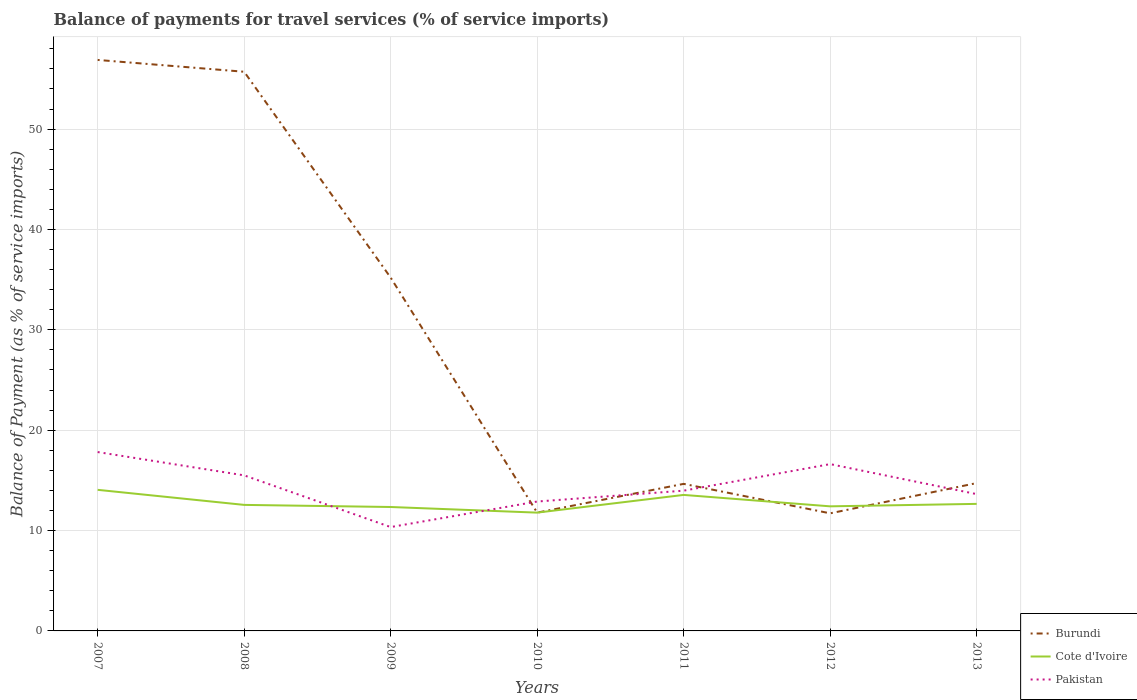Is the number of lines equal to the number of legend labels?
Provide a short and direct response. Yes. Across all years, what is the maximum balance of payments for travel services in Cote d'Ivoire?
Your response must be concise. 11.79. What is the total balance of payments for travel services in Cote d'Ivoire in the graph?
Provide a short and direct response. 0.21. What is the difference between the highest and the second highest balance of payments for travel services in Pakistan?
Ensure brevity in your answer.  7.47. What is the difference between the highest and the lowest balance of payments for travel services in Burundi?
Offer a very short reply. 3. Is the balance of payments for travel services in Pakistan strictly greater than the balance of payments for travel services in Cote d'Ivoire over the years?
Provide a short and direct response. No. What is the difference between two consecutive major ticks on the Y-axis?
Offer a terse response. 10. Where does the legend appear in the graph?
Make the answer very short. Bottom right. How are the legend labels stacked?
Your answer should be very brief. Vertical. What is the title of the graph?
Keep it short and to the point. Balance of payments for travel services (% of service imports). Does "India" appear as one of the legend labels in the graph?
Offer a terse response. No. What is the label or title of the Y-axis?
Your response must be concise. Balance of Payment (as % of service imports). What is the Balance of Payment (as % of service imports) of Burundi in 2007?
Make the answer very short. 56.89. What is the Balance of Payment (as % of service imports) of Cote d'Ivoire in 2007?
Your response must be concise. 14.06. What is the Balance of Payment (as % of service imports) in Pakistan in 2007?
Provide a succinct answer. 17.82. What is the Balance of Payment (as % of service imports) in Burundi in 2008?
Your answer should be compact. 55.71. What is the Balance of Payment (as % of service imports) in Cote d'Ivoire in 2008?
Keep it short and to the point. 12.56. What is the Balance of Payment (as % of service imports) in Pakistan in 2008?
Give a very brief answer. 15.5. What is the Balance of Payment (as % of service imports) of Burundi in 2009?
Make the answer very short. 35.2. What is the Balance of Payment (as % of service imports) in Cote d'Ivoire in 2009?
Give a very brief answer. 12.35. What is the Balance of Payment (as % of service imports) of Pakistan in 2009?
Ensure brevity in your answer.  10.35. What is the Balance of Payment (as % of service imports) of Burundi in 2010?
Offer a very short reply. 11.79. What is the Balance of Payment (as % of service imports) in Cote d'Ivoire in 2010?
Give a very brief answer. 11.79. What is the Balance of Payment (as % of service imports) in Pakistan in 2010?
Give a very brief answer. 12.89. What is the Balance of Payment (as % of service imports) in Burundi in 2011?
Your answer should be very brief. 14.65. What is the Balance of Payment (as % of service imports) of Cote d'Ivoire in 2011?
Your answer should be very brief. 13.55. What is the Balance of Payment (as % of service imports) in Pakistan in 2011?
Give a very brief answer. 13.97. What is the Balance of Payment (as % of service imports) in Burundi in 2012?
Give a very brief answer. 11.72. What is the Balance of Payment (as % of service imports) of Cote d'Ivoire in 2012?
Give a very brief answer. 12.41. What is the Balance of Payment (as % of service imports) in Pakistan in 2012?
Give a very brief answer. 16.62. What is the Balance of Payment (as % of service imports) in Burundi in 2013?
Ensure brevity in your answer.  14.73. What is the Balance of Payment (as % of service imports) in Cote d'Ivoire in 2013?
Provide a succinct answer. 12.66. What is the Balance of Payment (as % of service imports) in Pakistan in 2013?
Give a very brief answer. 13.63. Across all years, what is the maximum Balance of Payment (as % of service imports) in Burundi?
Keep it short and to the point. 56.89. Across all years, what is the maximum Balance of Payment (as % of service imports) of Cote d'Ivoire?
Your answer should be compact. 14.06. Across all years, what is the maximum Balance of Payment (as % of service imports) of Pakistan?
Give a very brief answer. 17.82. Across all years, what is the minimum Balance of Payment (as % of service imports) in Burundi?
Give a very brief answer. 11.72. Across all years, what is the minimum Balance of Payment (as % of service imports) in Cote d'Ivoire?
Ensure brevity in your answer.  11.79. Across all years, what is the minimum Balance of Payment (as % of service imports) in Pakistan?
Ensure brevity in your answer.  10.35. What is the total Balance of Payment (as % of service imports) in Burundi in the graph?
Your response must be concise. 200.68. What is the total Balance of Payment (as % of service imports) of Cote d'Ivoire in the graph?
Offer a terse response. 89.37. What is the total Balance of Payment (as % of service imports) in Pakistan in the graph?
Make the answer very short. 100.78. What is the difference between the Balance of Payment (as % of service imports) in Burundi in 2007 and that in 2008?
Your answer should be compact. 1.18. What is the difference between the Balance of Payment (as % of service imports) in Pakistan in 2007 and that in 2008?
Provide a short and direct response. 2.32. What is the difference between the Balance of Payment (as % of service imports) in Burundi in 2007 and that in 2009?
Offer a terse response. 21.69. What is the difference between the Balance of Payment (as % of service imports) of Cote d'Ivoire in 2007 and that in 2009?
Your answer should be compact. 1.71. What is the difference between the Balance of Payment (as % of service imports) in Pakistan in 2007 and that in 2009?
Provide a short and direct response. 7.47. What is the difference between the Balance of Payment (as % of service imports) of Burundi in 2007 and that in 2010?
Your answer should be compact. 45.1. What is the difference between the Balance of Payment (as % of service imports) of Cote d'Ivoire in 2007 and that in 2010?
Offer a terse response. 2.27. What is the difference between the Balance of Payment (as % of service imports) in Pakistan in 2007 and that in 2010?
Your answer should be compact. 4.93. What is the difference between the Balance of Payment (as % of service imports) of Burundi in 2007 and that in 2011?
Ensure brevity in your answer.  42.24. What is the difference between the Balance of Payment (as % of service imports) in Cote d'Ivoire in 2007 and that in 2011?
Provide a short and direct response. 0.51. What is the difference between the Balance of Payment (as % of service imports) in Pakistan in 2007 and that in 2011?
Give a very brief answer. 3.85. What is the difference between the Balance of Payment (as % of service imports) in Burundi in 2007 and that in 2012?
Your answer should be compact. 45.17. What is the difference between the Balance of Payment (as % of service imports) of Cote d'Ivoire in 2007 and that in 2012?
Your response must be concise. 1.64. What is the difference between the Balance of Payment (as % of service imports) in Pakistan in 2007 and that in 2012?
Offer a very short reply. 1.2. What is the difference between the Balance of Payment (as % of service imports) in Burundi in 2007 and that in 2013?
Make the answer very short. 42.16. What is the difference between the Balance of Payment (as % of service imports) in Cote d'Ivoire in 2007 and that in 2013?
Ensure brevity in your answer.  1.4. What is the difference between the Balance of Payment (as % of service imports) of Pakistan in 2007 and that in 2013?
Make the answer very short. 4.19. What is the difference between the Balance of Payment (as % of service imports) in Burundi in 2008 and that in 2009?
Make the answer very short. 20.51. What is the difference between the Balance of Payment (as % of service imports) in Cote d'Ivoire in 2008 and that in 2009?
Make the answer very short. 0.21. What is the difference between the Balance of Payment (as % of service imports) of Pakistan in 2008 and that in 2009?
Provide a short and direct response. 5.15. What is the difference between the Balance of Payment (as % of service imports) in Burundi in 2008 and that in 2010?
Offer a very short reply. 43.93. What is the difference between the Balance of Payment (as % of service imports) of Cote d'Ivoire in 2008 and that in 2010?
Provide a short and direct response. 0.77. What is the difference between the Balance of Payment (as % of service imports) in Pakistan in 2008 and that in 2010?
Provide a succinct answer. 2.61. What is the difference between the Balance of Payment (as % of service imports) of Burundi in 2008 and that in 2011?
Your answer should be compact. 41.06. What is the difference between the Balance of Payment (as % of service imports) of Cote d'Ivoire in 2008 and that in 2011?
Your answer should be very brief. -0.99. What is the difference between the Balance of Payment (as % of service imports) of Pakistan in 2008 and that in 2011?
Keep it short and to the point. 1.52. What is the difference between the Balance of Payment (as % of service imports) of Burundi in 2008 and that in 2012?
Make the answer very short. 44. What is the difference between the Balance of Payment (as % of service imports) of Cote d'Ivoire in 2008 and that in 2012?
Provide a short and direct response. 0.14. What is the difference between the Balance of Payment (as % of service imports) in Pakistan in 2008 and that in 2012?
Your response must be concise. -1.12. What is the difference between the Balance of Payment (as % of service imports) in Burundi in 2008 and that in 2013?
Your response must be concise. 40.98. What is the difference between the Balance of Payment (as % of service imports) of Cote d'Ivoire in 2008 and that in 2013?
Your answer should be compact. -0.1. What is the difference between the Balance of Payment (as % of service imports) in Pakistan in 2008 and that in 2013?
Your response must be concise. 1.87. What is the difference between the Balance of Payment (as % of service imports) of Burundi in 2009 and that in 2010?
Provide a succinct answer. 23.42. What is the difference between the Balance of Payment (as % of service imports) of Cote d'Ivoire in 2009 and that in 2010?
Make the answer very short. 0.56. What is the difference between the Balance of Payment (as % of service imports) in Pakistan in 2009 and that in 2010?
Make the answer very short. -2.55. What is the difference between the Balance of Payment (as % of service imports) of Burundi in 2009 and that in 2011?
Offer a very short reply. 20.55. What is the difference between the Balance of Payment (as % of service imports) of Cote d'Ivoire in 2009 and that in 2011?
Offer a terse response. -1.2. What is the difference between the Balance of Payment (as % of service imports) of Pakistan in 2009 and that in 2011?
Give a very brief answer. -3.63. What is the difference between the Balance of Payment (as % of service imports) in Burundi in 2009 and that in 2012?
Keep it short and to the point. 23.48. What is the difference between the Balance of Payment (as % of service imports) in Cote d'Ivoire in 2009 and that in 2012?
Make the answer very short. -0.07. What is the difference between the Balance of Payment (as % of service imports) in Pakistan in 2009 and that in 2012?
Provide a succinct answer. -6.27. What is the difference between the Balance of Payment (as % of service imports) in Burundi in 2009 and that in 2013?
Keep it short and to the point. 20.47. What is the difference between the Balance of Payment (as % of service imports) in Cote d'Ivoire in 2009 and that in 2013?
Offer a very short reply. -0.31. What is the difference between the Balance of Payment (as % of service imports) in Pakistan in 2009 and that in 2013?
Ensure brevity in your answer.  -3.28. What is the difference between the Balance of Payment (as % of service imports) in Burundi in 2010 and that in 2011?
Make the answer very short. -2.87. What is the difference between the Balance of Payment (as % of service imports) of Cote d'Ivoire in 2010 and that in 2011?
Provide a short and direct response. -1.76. What is the difference between the Balance of Payment (as % of service imports) in Pakistan in 2010 and that in 2011?
Make the answer very short. -1.08. What is the difference between the Balance of Payment (as % of service imports) in Burundi in 2010 and that in 2012?
Provide a succinct answer. 0.07. What is the difference between the Balance of Payment (as % of service imports) of Cote d'Ivoire in 2010 and that in 2012?
Give a very brief answer. -0.63. What is the difference between the Balance of Payment (as % of service imports) of Pakistan in 2010 and that in 2012?
Offer a terse response. -3.73. What is the difference between the Balance of Payment (as % of service imports) of Burundi in 2010 and that in 2013?
Provide a short and direct response. -2.94. What is the difference between the Balance of Payment (as % of service imports) of Cote d'Ivoire in 2010 and that in 2013?
Keep it short and to the point. -0.87. What is the difference between the Balance of Payment (as % of service imports) of Pakistan in 2010 and that in 2013?
Provide a succinct answer. -0.74. What is the difference between the Balance of Payment (as % of service imports) of Burundi in 2011 and that in 2012?
Offer a very short reply. 2.94. What is the difference between the Balance of Payment (as % of service imports) of Cote d'Ivoire in 2011 and that in 2012?
Your answer should be compact. 1.14. What is the difference between the Balance of Payment (as % of service imports) in Pakistan in 2011 and that in 2012?
Your answer should be very brief. -2.64. What is the difference between the Balance of Payment (as % of service imports) in Burundi in 2011 and that in 2013?
Your answer should be compact. -0.08. What is the difference between the Balance of Payment (as % of service imports) of Cote d'Ivoire in 2011 and that in 2013?
Provide a short and direct response. 0.89. What is the difference between the Balance of Payment (as % of service imports) in Pakistan in 2011 and that in 2013?
Make the answer very short. 0.34. What is the difference between the Balance of Payment (as % of service imports) of Burundi in 2012 and that in 2013?
Your answer should be very brief. -3.01. What is the difference between the Balance of Payment (as % of service imports) of Cote d'Ivoire in 2012 and that in 2013?
Make the answer very short. -0.25. What is the difference between the Balance of Payment (as % of service imports) in Pakistan in 2012 and that in 2013?
Offer a terse response. 2.99. What is the difference between the Balance of Payment (as % of service imports) of Burundi in 2007 and the Balance of Payment (as % of service imports) of Cote d'Ivoire in 2008?
Offer a terse response. 44.33. What is the difference between the Balance of Payment (as % of service imports) in Burundi in 2007 and the Balance of Payment (as % of service imports) in Pakistan in 2008?
Provide a succinct answer. 41.39. What is the difference between the Balance of Payment (as % of service imports) in Cote d'Ivoire in 2007 and the Balance of Payment (as % of service imports) in Pakistan in 2008?
Offer a very short reply. -1.44. What is the difference between the Balance of Payment (as % of service imports) in Burundi in 2007 and the Balance of Payment (as % of service imports) in Cote d'Ivoire in 2009?
Ensure brevity in your answer.  44.54. What is the difference between the Balance of Payment (as % of service imports) in Burundi in 2007 and the Balance of Payment (as % of service imports) in Pakistan in 2009?
Offer a very short reply. 46.54. What is the difference between the Balance of Payment (as % of service imports) of Cote d'Ivoire in 2007 and the Balance of Payment (as % of service imports) of Pakistan in 2009?
Offer a terse response. 3.71. What is the difference between the Balance of Payment (as % of service imports) of Burundi in 2007 and the Balance of Payment (as % of service imports) of Cote d'Ivoire in 2010?
Your answer should be compact. 45.1. What is the difference between the Balance of Payment (as % of service imports) in Burundi in 2007 and the Balance of Payment (as % of service imports) in Pakistan in 2010?
Your answer should be compact. 44. What is the difference between the Balance of Payment (as % of service imports) in Cote d'Ivoire in 2007 and the Balance of Payment (as % of service imports) in Pakistan in 2010?
Keep it short and to the point. 1.16. What is the difference between the Balance of Payment (as % of service imports) in Burundi in 2007 and the Balance of Payment (as % of service imports) in Cote d'Ivoire in 2011?
Provide a succinct answer. 43.34. What is the difference between the Balance of Payment (as % of service imports) of Burundi in 2007 and the Balance of Payment (as % of service imports) of Pakistan in 2011?
Keep it short and to the point. 42.91. What is the difference between the Balance of Payment (as % of service imports) of Cote d'Ivoire in 2007 and the Balance of Payment (as % of service imports) of Pakistan in 2011?
Ensure brevity in your answer.  0.08. What is the difference between the Balance of Payment (as % of service imports) in Burundi in 2007 and the Balance of Payment (as % of service imports) in Cote d'Ivoire in 2012?
Give a very brief answer. 44.48. What is the difference between the Balance of Payment (as % of service imports) in Burundi in 2007 and the Balance of Payment (as % of service imports) in Pakistan in 2012?
Your answer should be very brief. 40.27. What is the difference between the Balance of Payment (as % of service imports) in Cote d'Ivoire in 2007 and the Balance of Payment (as % of service imports) in Pakistan in 2012?
Offer a terse response. -2.56. What is the difference between the Balance of Payment (as % of service imports) in Burundi in 2007 and the Balance of Payment (as % of service imports) in Cote d'Ivoire in 2013?
Provide a short and direct response. 44.23. What is the difference between the Balance of Payment (as % of service imports) of Burundi in 2007 and the Balance of Payment (as % of service imports) of Pakistan in 2013?
Your answer should be compact. 43.26. What is the difference between the Balance of Payment (as % of service imports) of Cote d'Ivoire in 2007 and the Balance of Payment (as % of service imports) of Pakistan in 2013?
Offer a terse response. 0.43. What is the difference between the Balance of Payment (as % of service imports) of Burundi in 2008 and the Balance of Payment (as % of service imports) of Cote d'Ivoire in 2009?
Keep it short and to the point. 43.37. What is the difference between the Balance of Payment (as % of service imports) of Burundi in 2008 and the Balance of Payment (as % of service imports) of Pakistan in 2009?
Ensure brevity in your answer.  45.36. What is the difference between the Balance of Payment (as % of service imports) in Cote d'Ivoire in 2008 and the Balance of Payment (as % of service imports) in Pakistan in 2009?
Your answer should be compact. 2.21. What is the difference between the Balance of Payment (as % of service imports) in Burundi in 2008 and the Balance of Payment (as % of service imports) in Cote d'Ivoire in 2010?
Give a very brief answer. 43.92. What is the difference between the Balance of Payment (as % of service imports) of Burundi in 2008 and the Balance of Payment (as % of service imports) of Pakistan in 2010?
Offer a very short reply. 42.82. What is the difference between the Balance of Payment (as % of service imports) in Cote d'Ivoire in 2008 and the Balance of Payment (as % of service imports) in Pakistan in 2010?
Your answer should be very brief. -0.34. What is the difference between the Balance of Payment (as % of service imports) of Burundi in 2008 and the Balance of Payment (as % of service imports) of Cote d'Ivoire in 2011?
Provide a succinct answer. 42.16. What is the difference between the Balance of Payment (as % of service imports) of Burundi in 2008 and the Balance of Payment (as % of service imports) of Pakistan in 2011?
Your response must be concise. 41.74. What is the difference between the Balance of Payment (as % of service imports) of Cote d'Ivoire in 2008 and the Balance of Payment (as % of service imports) of Pakistan in 2011?
Your answer should be very brief. -1.42. What is the difference between the Balance of Payment (as % of service imports) in Burundi in 2008 and the Balance of Payment (as % of service imports) in Cote d'Ivoire in 2012?
Your answer should be compact. 43.3. What is the difference between the Balance of Payment (as % of service imports) in Burundi in 2008 and the Balance of Payment (as % of service imports) in Pakistan in 2012?
Ensure brevity in your answer.  39.09. What is the difference between the Balance of Payment (as % of service imports) in Cote d'Ivoire in 2008 and the Balance of Payment (as % of service imports) in Pakistan in 2012?
Give a very brief answer. -4.06. What is the difference between the Balance of Payment (as % of service imports) in Burundi in 2008 and the Balance of Payment (as % of service imports) in Cote d'Ivoire in 2013?
Provide a succinct answer. 43.05. What is the difference between the Balance of Payment (as % of service imports) of Burundi in 2008 and the Balance of Payment (as % of service imports) of Pakistan in 2013?
Your response must be concise. 42.08. What is the difference between the Balance of Payment (as % of service imports) of Cote d'Ivoire in 2008 and the Balance of Payment (as % of service imports) of Pakistan in 2013?
Make the answer very short. -1.07. What is the difference between the Balance of Payment (as % of service imports) of Burundi in 2009 and the Balance of Payment (as % of service imports) of Cote d'Ivoire in 2010?
Your answer should be compact. 23.41. What is the difference between the Balance of Payment (as % of service imports) in Burundi in 2009 and the Balance of Payment (as % of service imports) in Pakistan in 2010?
Your response must be concise. 22.31. What is the difference between the Balance of Payment (as % of service imports) of Cote d'Ivoire in 2009 and the Balance of Payment (as % of service imports) of Pakistan in 2010?
Offer a very short reply. -0.55. What is the difference between the Balance of Payment (as % of service imports) of Burundi in 2009 and the Balance of Payment (as % of service imports) of Cote d'Ivoire in 2011?
Keep it short and to the point. 21.65. What is the difference between the Balance of Payment (as % of service imports) of Burundi in 2009 and the Balance of Payment (as % of service imports) of Pakistan in 2011?
Your response must be concise. 21.23. What is the difference between the Balance of Payment (as % of service imports) in Cote d'Ivoire in 2009 and the Balance of Payment (as % of service imports) in Pakistan in 2011?
Make the answer very short. -1.63. What is the difference between the Balance of Payment (as % of service imports) of Burundi in 2009 and the Balance of Payment (as % of service imports) of Cote d'Ivoire in 2012?
Provide a short and direct response. 22.79. What is the difference between the Balance of Payment (as % of service imports) in Burundi in 2009 and the Balance of Payment (as % of service imports) in Pakistan in 2012?
Your answer should be very brief. 18.58. What is the difference between the Balance of Payment (as % of service imports) of Cote d'Ivoire in 2009 and the Balance of Payment (as % of service imports) of Pakistan in 2012?
Offer a terse response. -4.27. What is the difference between the Balance of Payment (as % of service imports) in Burundi in 2009 and the Balance of Payment (as % of service imports) in Cote d'Ivoire in 2013?
Provide a succinct answer. 22.54. What is the difference between the Balance of Payment (as % of service imports) of Burundi in 2009 and the Balance of Payment (as % of service imports) of Pakistan in 2013?
Your answer should be very brief. 21.57. What is the difference between the Balance of Payment (as % of service imports) of Cote d'Ivoire in 2009 and the Balance of Payment (as % of service imports) of Pakistan in 2013?
Provide a succinct answer. -1.28. What is the difference between the Balance of Payment (as % of service imports) of Burundi in 2010 and the Balance of Payment (as % of service imports) of Cote d'Ivoire in 2011?
Provide a succinct answer. -1.77. What is the difference between the Balance of Payment (as % of service imports) in Burundi in 2010 and the Balance of Payment (as % of service imports) in Pakistan in 2011?
Give a very brief answer. -2.19. What is the difference between the Balance of Payment (as % of service imports) in Cote d'Ivoire in 2010 and the Balance of Payment (as % of service imports) in Pakistan in 2011?
Offer a terse response. -2.19. What is the difference between the Balance of Payment (as % of service imports) in Burundi in 2010 and the Balance of Payment (as % of service imports) in Cote d'Ivoire in 2012?
Make the answer very short. -0.63. What is the difference between the Balance of Payment (as % of service imports) of Burundi in 2010 and the Balance of Payment (as % of service imports) of Pakistan in 2012?
Your answer should be very brief. -4.83. What is the difference between the Balance of Payment (as % of service imports) in Cote d'Ivoire in 2010 and the Balance of Payment (as % of service imports) in Pakistan in 2012?
Make the answer very short. -4.83. What is the difference between the Balance of Payment (as % of service imports) in Burundi in 2010 and the Balance of Payment (as % of service imports) in Cote d'Ivoire in 2013?
Provide a succinct answer. -0.87. What is the difference between the Balance of Payment (as % of service imports) of Burundi in 2010 and the Balance of Payment (as % of service imports) of Pakistan in 2013?
Make the answer very short. -1.84. What is the difference between the Balance of Payment (as % of service imports) of Cote d'Ivoire in 2010 and the Balance of Payment (as % of service imports) of Pakistan in 2013?
Ensure brevity in your answer.  -1.84. What is the difference between the Balance of Payment (as % of service imports) of Burundi in 2011 and the Balance of Payment (as % of service imports) of Cote d'Ivoire in 2012?
Give a very brief answer. 2.24. What is the difference between the Balance of Payment (as % of service imports) of Burundi in 2011 and the Balance of Payment (as % of service imports) of Pakistan in 2012?
Offer a terse response. -1.97. What is the difference between the Balance of Payment (as % of service imports) in Cote d'Ivoire in 2011 and the Balance of Payment (as % of service imports) in Pakistan in 2012?
Your answer should be compact. -3.07. What is the difference between the Balance of Payment (as % of service imports) of Burundi in 2011 and the Balance of Payment (as % of service imports) of Cote d'Ivoire in 2013?
Your answer should be very brief. 1.99. What is the difference between the Balance of Payment (as % of service imports) of Burundi in 2011 and the Balance of Payment (as % of service imports) of Pakistan in 2013?
Keep it short and to the point. 1.02. What is the difference between the Balance of Payment (as % of service imports) in Cote d'Ivoire in 2011 and the Balance of Payment (as % of service imports) in Pakistan in 2013?
Your answer should be compact. -0.08. What is the difference between the Balance of Payment (as % of service imports) of Burundi in 2012 and the Balance of Payment (as % of service imports) of Cote d'Ivoire in 2013?
Provide a succinct answer. -0.94. What is the difference between the Balance of Payment (as % of service imports) in Burundi in 2012 and the Balance of Payment (as % of service imports) in Pakistan in 2013?
Ensure brevity in your answer.  -1.91. What is the difference between the Balance of Payment (as % of service imports) in Cote d'Ivoire in 2012 and the Balance of Payment (as % of service imports) in Pakistan in 2013?
Ensure brevity in your answer.  -1.22. What is the average Balance of Payment (as % of service imports) of Burundi per year?
Keep it short and to the point. 28.67. What is the average Balance of Payment (as % of service imports) of Cote d'Ivoire per year?
Your answer should be very brief. 12.77. What is the average Balance of Payment (as % of service imports) of Pakistan per year?
Your answer should be compact. 14.4. In the year 2007, what is the difference between the Balance of Payment (as % of service imports) in Burundi and Balance of Payment (as % of service imports) in Cote d'Ivoire?
Offer a terse response. 42.83. In the year 2007, what is the difference between the Balance of Payment (as % of service imports) of Burundi and Balance of Payment (as % of service imports) of Pakistan?
Your answer should be compact. 39.07. In the year 2007, what is the difference between the Balance of Payment (as % of service imports) of Cote d'Ivoire and Balance of Payment (as % of service imports) of Pakistan?
Offer a very short reply. -3.76. In the year 2008, what is the difference between the Balance of Payment (as % of service imports) of Burundi and Balance of Payment (as % of service imports) of Cote d'Ivoire?
Provide a short and direct response. 43.16. In the year 2008, what is the difference between the Balance of Payment (as % of service imports) in Burundi and Balance of Payment (as % of service imports) in Pakistan?
Your answer should be compact. 40.21. In the year 2008, what is the difference between the Balance of Payment (as % of service imports) in Cote d'Ivoire and Balance of Payment (as % of service imports) in Pakistan?
Give a very brief answer. -2.94. In the year 2009, what is the difference between the Balance of Payment (as % of service imports) in Burundi and Balance of Payment (as % of service imports) in Cote d'Ivoire?
Your response must be concise. 22.85. In the year 2009, what is the difference between the Balance of Payment (as % of service imports) in Burundi and Balance of Payment (as % of service imports) in Pakistan?
Make the answer very short. 24.85. In the year 2009, what is the difference between the Balance of Payment (as % of service imports) of Cote d'Ivoire and Balance of Payment (as % of service imports) of Pakistan?
Provide a short and direct response. 2. In the year 2010, what is the difference between the Balance of Payment (as % of service imports) in Burundi and Balance of Payment (as % of service imports) in Cote d'Ivoire?
Make the answer very short. -0. In the year 2010, what is the difference between the Balance of Payment (as % of service imports) of Burundi and Balance of Payment (as % of service imports) of Pakistan?
Offer a very short reply. -1.11. In the year 2010, what is the difference between the Balance of Payment (as % of service imports) in Cote d'Ivoire and Balance of Payment (as % of service imports) in Pakistan?
Make the answer very short. -1.11. In the year 2011, what is the difference between the Balance of Payment (as % of service imports) of Burundi and Balance of Payment (as % of service imports) of Cote d'Ivoire?
Your answer should be compact. 1.1. In the year 2011, what is the difference between the Balance of Payment (as % of service imports) of Burundi and Balance of Payment (as % of service imports) of Pakistan?
Give a very brief answer. 0.68. In the year 2011, what is the difference between the Balance of Payment (as % of service imports) of Cote d'Ivoire and Balance of Payment (as % of service imports) of Pakistan?
Offer a terse response. -0.42. In the year 2012, what is the difference between the Balance of Payment (as % of service imports) of Burundi and Balance of Payment (as % of service imports) of Cote d'Ivoire?
Make the answer very short. -0.7. In the year 2012, what is the difference between the Balance of Payment (as % of service imports) in Burundi and Balance of Payment (as % of service imports) in Pakistan?
Make the answer very short. -4.9. In the year 2012, what is the difference between the Balance of Payment (as % of service imports) in Cote d'Ivoire and Balance of Payment (as % of service imports) in Pakistan?
Your response must be concise. -4.21. In the year 2013, what is the difference between the Balance of Payment (as % of service imports) of Burundi and Balance of Payment (as % of service imports) of Cote d'Ivoire?
Offer a terse response. 2.07. In the year 2013, what is the difference between the Balance of Payment (as % of service imports) of Burundi and Balance of Payment (as % of service imports) of Pakistan?
Offer a very short reply. 1.1. In the year 2013, what is the difference between the Balance of Payment (as % of service imports) of Cote d'Ivoire and Balance of Payment (as % of service imports) of Pakistan?
Your answer should be compact. -0.97. What is the ratio of the Balance of Payment (as % of service imports) in Burundi in 2007 to that in 2008?
Offer a very short reply. 1.02. What is the ratio of the Balance of Payment (as % of service imports) of Cote d'Ivoire in 2007 to that in 2008?
Make the answer very short. 1.12. What is the ratio of the Balance of Payment (as % of service imports) in Pakistan in 2007 to that in 2008?
Give a very brief answer. 1.15. What is the ratio of the Balance of Payment (as % of service imports) in Burundi in 2007 to that in 2009?
Offer a terse response. 1.62. What is the ratio of the Balance of Payment (as % of service imports) in Cote d'Ivoire in 2007 to that in 2009?
Make the answer very short. 1.14. What is the ratio of the Balance of Payment (as % of service imports) of Pakistan in 2007 to that in 2009?
Your answer should be very brief. 1.72. What is the ratio of the Balance of Payment (as % of service imports) in Burundi in 2007 to that in 2010?
Provide a short and direct response. 4.83. What is the ratio of the Balance of Payment (as % of service imports) of Cote d'Ivoire in 2007 to that in 2010?
Keep it short and to the point. 1.19. What is the ratio of the Balance of Payment (as % of service imports) in Pakistan in 2007 to that in 2010?
Ensure brevity in your answer.  1.38. What is the ratio of the Balance of Payment (as % of service imports) of Burundi in 2007 to that in 2011?
Your answer should be compact. 3.88. What is the ratio of the Balance of Payment (as % of service imports) of Cote d'Ivoire in 2007 to that in 2011?
Your answer should be very brief. 1.04. What is the ratio of the Balance of Payment (as % of service imports) of Pakistan in 2007 to that in 2011?
Make the answer very short. 1.28. What is the ratio of the Balance of Payment (as % of service imports) in Burundi in 2007 to that in 2012?
Your answer should be very brief. 4.86. What is the ratio of the Balance of Payment (as % of service imports) in Cote d'Ivoire in 2007 to that in 2012?
Make the answer very short. 1.13. What is the ratio of the Balance of Payment (as % of service imports) in Pakistan in 2007 to that in 2012?
Make the answer very short. 1.07. What is the ratio of the Balance of Payment (as % of service imports) of Burundi in 2007 to that in 2013?
Offer a very short reply. 3.86. What is the ratio of the Balance of Payment (as % of service imports) in Cote d'Ivoire in 2007 to that in 2013?
Keep it short and to the point. 1.11. What is the ratio of the Balance of Payment (as % of service imports) of Pakistan in 2007 to that in 2013?
Offer a very short reply. 1.31. What is the ratio of the Balance of Payment (as % of service imports) of Burundi in 2008 to that in 2009?
Provide a short and direct response. 1.58. What is the ratio of the Balance of Payment (as % of service imports) in Pakistan in 2008 to that in 2009?
Your response must be concise. 1.5. What is the ratio of the Balance of Payment (as % of service imports) of Burundi in 2008 to that in 2010?
Give a very brief answer. 4.73. What is the ratio of the Balance of Payment (as % of service imports) in Cote d'Ivoire in 2008 to that in 2010?
Make the answer very short. 1.07. What is the ratio of the Balance of Payment (as % of service imports) of Pakistan in 2008 to that in 2010?
Provide a short and direct response. 1.2. What is the ratio of the Balance of Payment (as % of service imports) in Burundi in 2008 to that in 2011?
Keep it short and to the point. 3.8. What is the ratio of the Balance of Payment (as % of service imports) in Cote d'Ivoire in 2008 to that in 2011?
Give a very brief answer. 0.93. What is the ratio of the Balance of Payment (as % of service imports) in Pakistan in 2008 to that in 2011?
Your answer should be compact. 1.11. What is the ratio of the Balance of Payment (as % of service imports) of Burundi in 2008 to that in 2012?
Your answer should be very brief. 4.75. What is the ratio of the Balance of Payment (as % of service imports) of Cote d'Ivoire in 2008 to that in 2012?
Your answer should be very brief. 1.01. What is the ratio of the Balance of Payment (as % of service imports) of Pakistan in 2008 to that in 2012?
Keep it short and to the point. 0.93. What is the ratio of the Balance of Payment (as % of service imports) of Burundi in 2008 to that in 2013?
Your response must be concise. 3.78. What is the ratio of the Balance of Payment (as % of service imports) in Pakistan in 2008 to that in 2013?
Provide a succinct answer. 1.14. What is the ratio of the Balance of Payment (as % of service imports) of Burundi in 2009 to that in 2010?
Your answer should be compact. 2.99. What is the ratio of the Balance of Payment (as % of service imports) in Cote d'Ivoire in 2009 to that in 2010?
Provide a short and direct response. 1.05. What is the ratio of the Balance of Payment (as % of service imports) of Pakistan in 2009 to that in 2010?
Offer a terse response. 0.8. What is the ratio of the Balance of Payment (as % of service imports) of Burundi in 2009 to that in 2011?
Offer a very short reply. 2.4. What is the ratio of the Balance of Payment (as % of service imports) of Cote d'Ivoire in 2009 to that in 2011?
Make the answer very short. 0.91. What is the ratio of the Balance of Payment (as % of service imports) of Pakistan in 2009 to that in 2011?
Offer a terse response. 0.74. What is the ratio of the Balance of Payment (as % of service imports) in Burundi in 2009 to that in 2012?
Keep it short and to the point. 3. What is the ratio of the Balance of Payment (as % of service imports) of Cote d'Ivoire in 2009 to that in 2012?
Ensure brevity in your answer.  0.99. What is the ratio of the Balance of Payment (as % of service imports) in Pakistan in 2009 to that in 2012?
Make the answer very short. 0.62. What is the ratio of the Balance of Payment (as % of service imports) of Burundi in 2009 to that in 2013?
Offer a very short reply. 2.39. What is the ratio of the Balance of Payment (as % of service imports) in Cote d'Ivoire in 2009 to that in 2013?
Provide a succinct answer. 0.98. What is the ratio of the Balance of Payment (as % of service imports) of Pakistan in 2009 to that in 2013?
Ensure brevity in your answer.  0.76. What is the ratio of the Balance of Payment (as % of service imports) of Burundi in 2010 to that in 2011?
Keep it short and to the point. 0.8. What is the ratio of the Balance of Payment (as % of service imports) of Cote d'Ivoire in 2010 to that in 2011?
Your response must be concise. 0.87. What is the ratio of the Balance of Payment (as % of service imports) in Pakistan in 2010 to that in 2011?
Ensure brevity in your answer.  0.92. What is the ratio of the Balance of Payment (as % of service imports) of Burundi in 2010 to that in 2012?
Provide a succinct answer. 1.01. What is the ratio of the Balance of Payment (as % of service imports) of Cote d'Ivoire in 2010 to that in 2012?
Make the answer very short. 0.95. What is the ratio of the Balance of Payment (as % of service imports) in Pakistan in 2010 to that in 2012?
Make the answer very short. 0.78. What is the ratio of the Balance of Payment (as % of service imports) of Burundi in 2010 to that in 2013?
Offer a very short reply. 0.8. What is the ratio of the Balance of Payment (as % of service imports) of Cote d'Ivoire in 2010 to that in 2013?
Make the answer very short. 0.93. What is the ratio of the Balance of Payment (as % of service imports) in Pakistan in 2010 to that in 2013?
Ensure brevity in your answer.  0.95. What is the ratio of the Balance of Payment (as % of service imports) of Burundi in 2011 to that in 2012?
Provide a short and direct response. 1.25. What is the ratio of the Balance of Payment (as % of service imports) of Cote d'Ivoire in 2011 to that in 2012?
Keep it short and to the point. 1.09. What is the ratio of the Balance of Payment (as % of service imports) of Pakistan in 2011 to that in 2012?
Offer a very short reply. 0.84. What is the ratio of the Balance of Payment (as % of service imports) of Cote d'Ivoire in 2011 to that in 2013?
Give a very brief answer. 1.07. What is the ratio of the Balance of Payment (as % of service imports) of Pakistan in 2011 to that in 2013?
Give a very brief answer. 1.03. What is the ratio of the Balance of Payment (as % of service imports) in Burundi in 2012 to that in 2013?
Offer a terse response. 0.8. What is the ratio of the Balance of Payment (as % of service imports) in Cote d'Ivoire in 2012 to that in 2013?
Offer a terse response. 0.98. What is the ratio of the Balance of Payment (as % of service imports) of Pakistan in 2012 to that in 2013?
Your answer should be compact. 1.22. What is the difference between the highest and the second highest Balance of Payment (as % of service imports) in Burundi?
Give a very brief answer. 1.18. What is the difference between the highest and the second highest Balance of Payment (as % of service imports) of Cote d'Ivoire?
Your answer should be compact. 0.51. What is the difference between the highest and the second highest Balance of Payment (as % of service imports) of Pakistan?
Ensure brevity in your answer.  1.2. What is the difference between the highest and the lowest Balance of Payment (as % of service imports) in Burundi?
Make the answer very short. 45.17. What is the difference between the highest and the lowest Balance of Payment (as % of service imports) of Cote d'Ivoire?
Your answer should be very brief. 2.27. What is the difference between the highest and the lowest Balance of Payment (as % of service imports) of Pakistan?
Your answer should be compact. 7.47. 